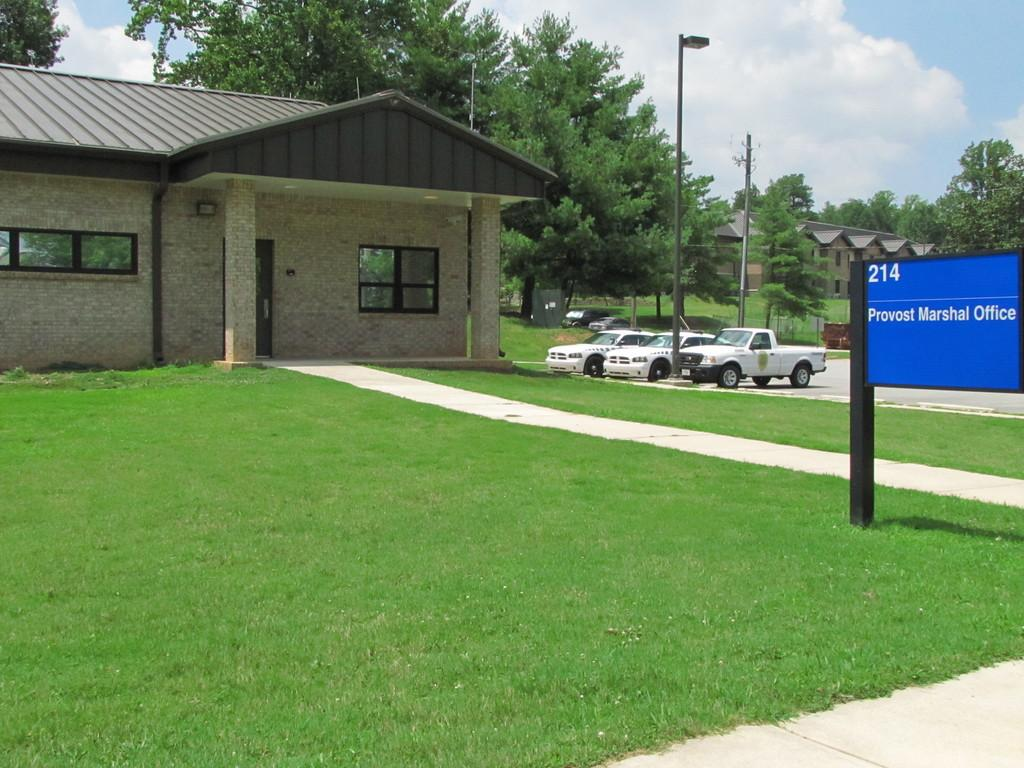What type of structures can be seen in the image? There are houses in the image. What natural elements are present in the image? There are trees in the image. What man-made objects can be seen in the image? There are poles and vehicles in the image. What is the ground like in the image? The ground with grass is visible in the image. What other objects can be seen in the image? There are objects in the image. Is there any text visible in the image? Yes, there is a board with text in the image. What can be seen in the sky in the image? The sky with clouds is visible in the image. Can you tell me how many drums are visible in the image? There are no drums present in the image. Is there a lake visible in the image? There is no lake present in the image. 